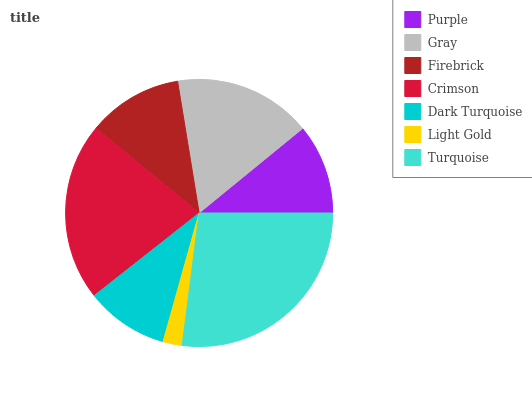Is Light Gold the minimum?
Answer yes or no. Yes. Is Turquoise the maximum?
Answer yes or no. Yes. Is Gray the minimum?
Answer yes or no. No. Is Gray the maximum?
Answer yes or no. No. Is Gray greater than Purple?
Answer yes or no. Yes. Is Purple less than Gray?
Answer yes or no. Yes. Is Purple greater than Gray?
Answer yes or no. No. Is Gray less than Purple?
Answer yes or no. No. Is Firebrick the high median?
Answer yes or no. Yes. Is Firebrick the low median?
Answer yes or no. Yes. Is Turquoise the high median?
Answer yes or no. No. Is Purple the low median?
Answer yes or no. No. 